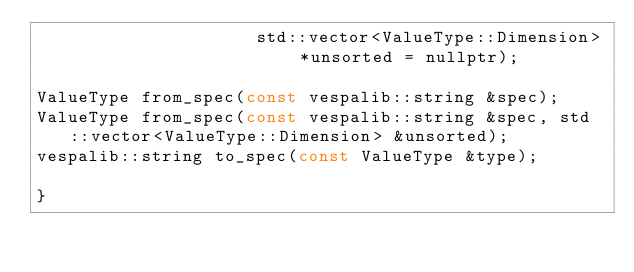<code> <loc_0><loc_0><loc_500><loc_500><_C_>                     std::vector<ValueType::Dimension> *unsorted = nullptr);

ValueType from_spec(const vespalib::string &spec);
ValueType from_spec(const vespalib::string &spec, std::vector<ValueType::Dimension> &unsorted);
vespalib::string to_spec(const ValueType &type);

}
</code> 